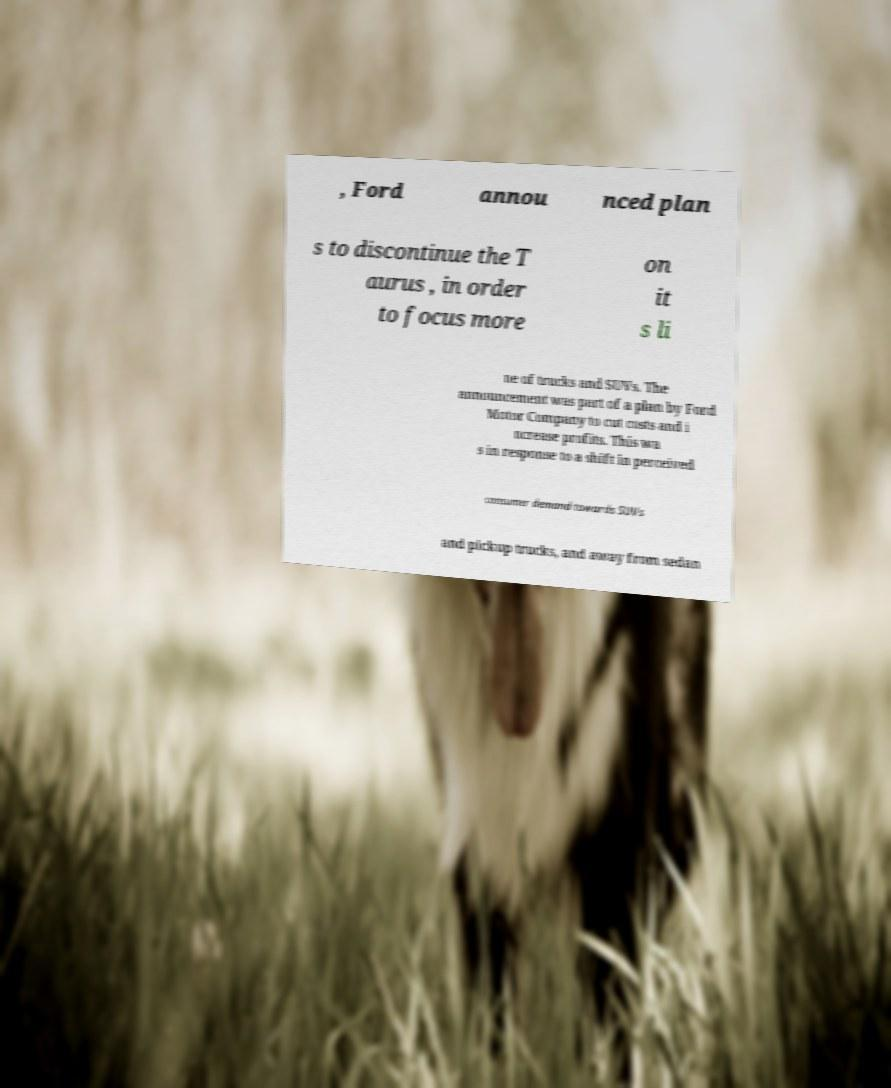Can you accurately transcribe the text from the provided image for me? , Ford annou nced plan s to discontinue the T aurus , in order to focus more on it s li ne of trucks and SUVs. The announcement was part of a plan by Ford Motor Company to cut costs and i ncrease profits. This wa s in response to a shift in perceived consumer demand towards SUVs and pickup trucks, and away from sedan 